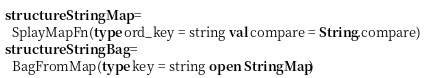Convert code to text. <code><loc_0><loc_0><loc_500><loc_500><_SML_>structure StringMap = 
  SplayMapFn(type ord_key = string val compare = String.compare)
structure StringBag = 
  BagFromMap(type key = string open StringMap)
</code> 